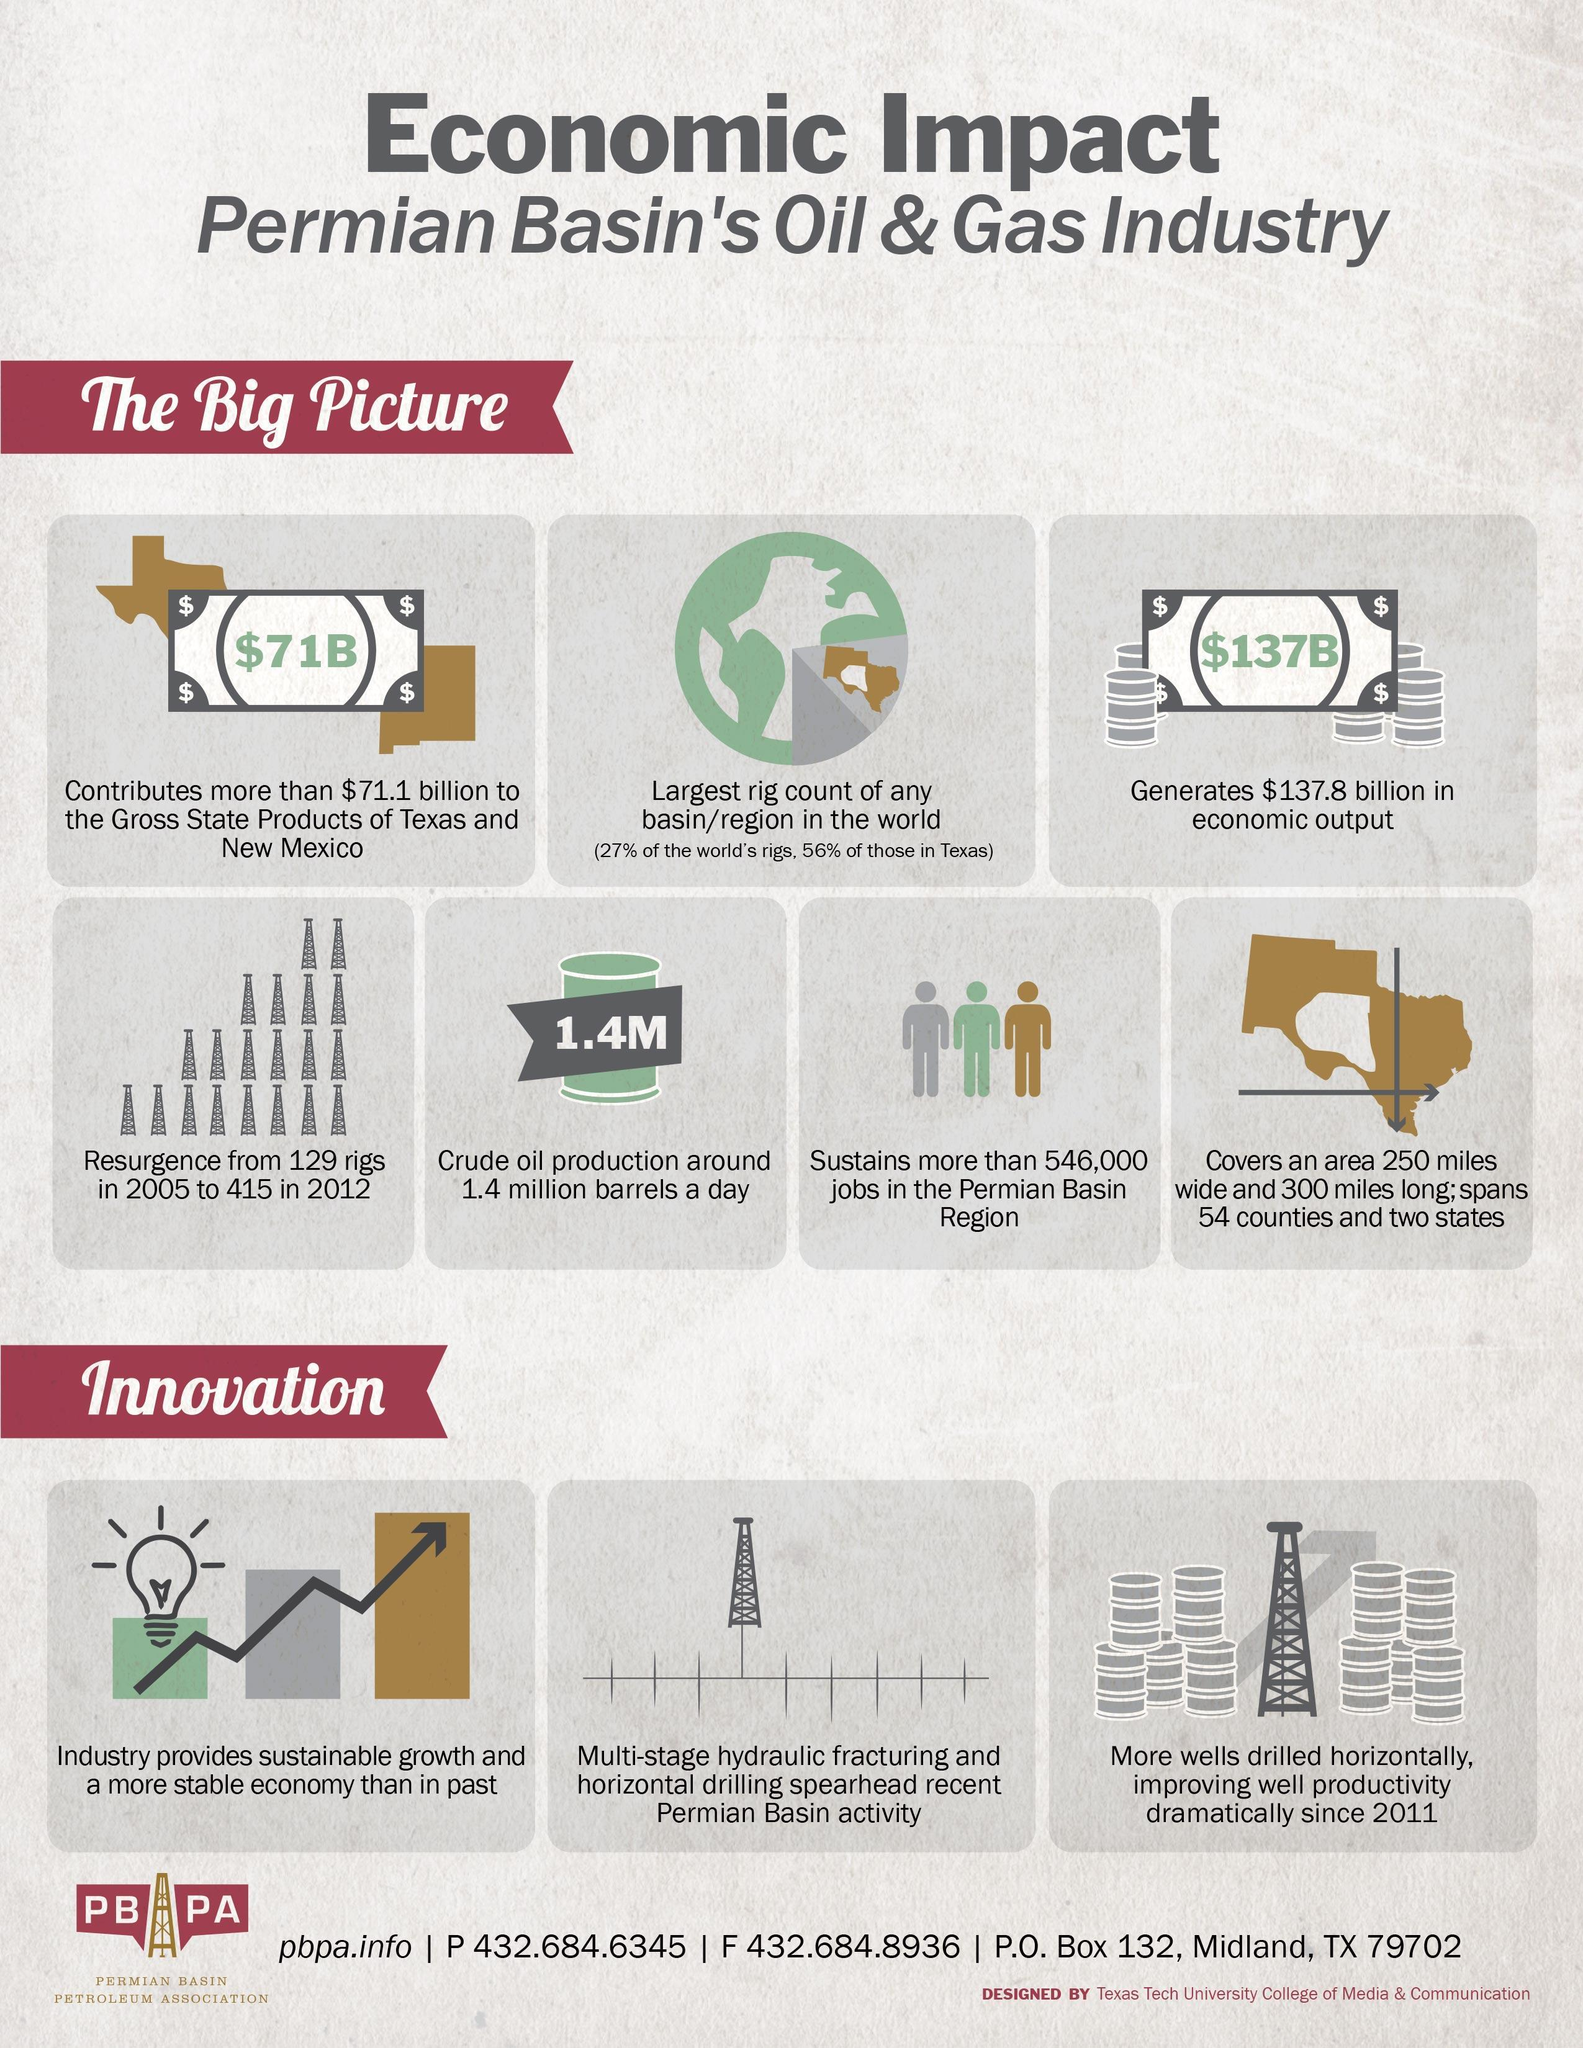How much total area does the Permian Basin's oil and gas industry cover?
Answer the question with a short phrase. 75,000 square miles What is the increase in resurgence of rigs from 2005 to 2012? 286 